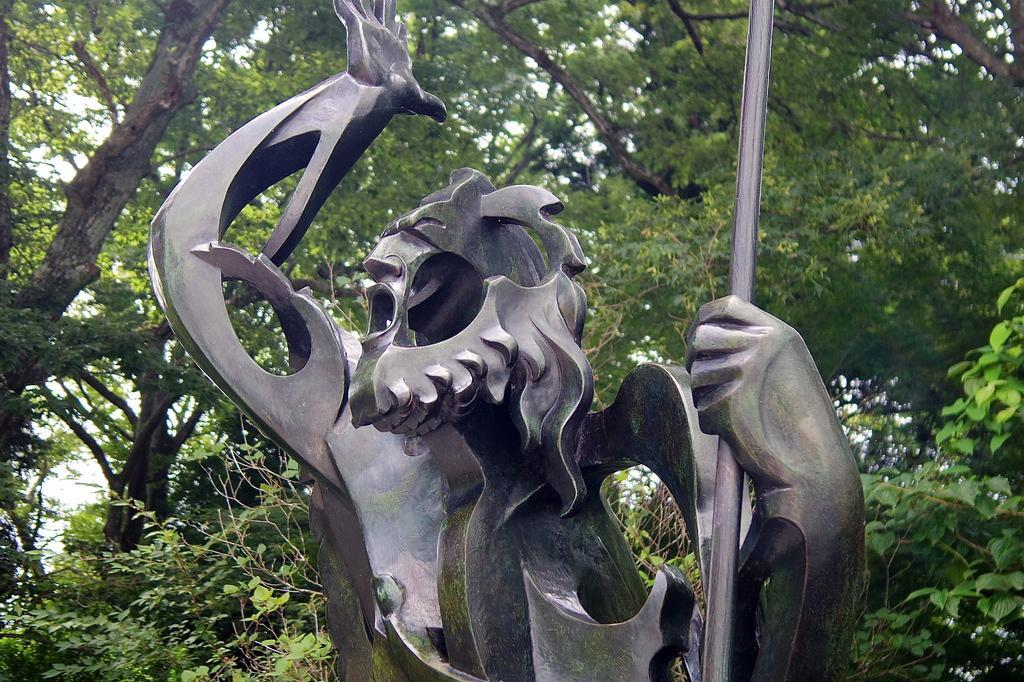Please provide a concise description of this image. In this image there is a sculpture. In the background there are trees. 